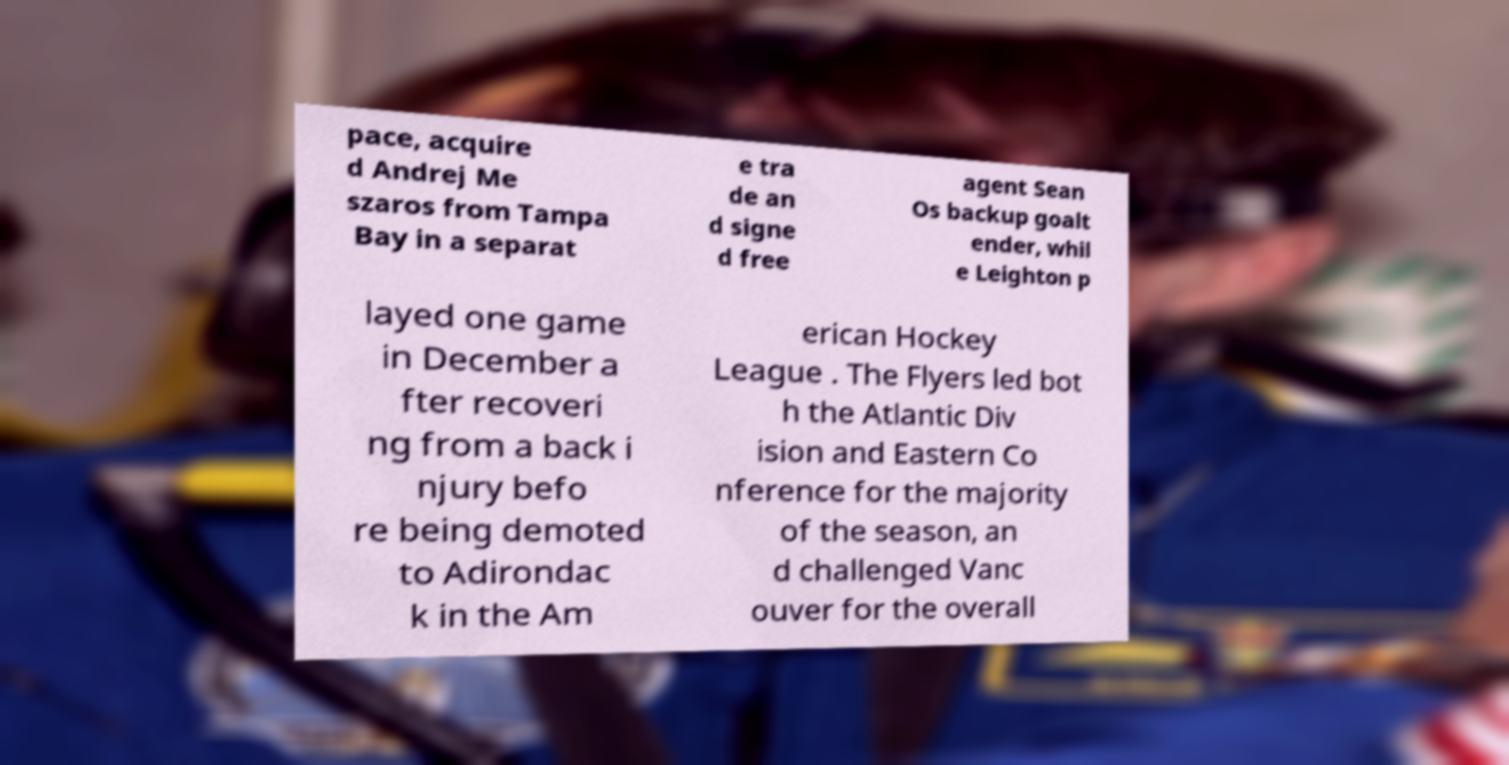For documentation purposes, I need the text within this image transcribed. Could you provide that? pace, acquire d Andrej Me szaros from Tampa Bay in a separat e tra de an d signe d free agent Sean Os backup goalt ender, whil e Leighton p layed one game in December a fter recoveri ng from a back i njury befo re being demoted to Adirondac k in the Am erican Hockey League . The Flyers led bot h the Atlantic Div ision and Eastern Co nference for the majority of the season, an d challenged Vanc ouver for the overall 